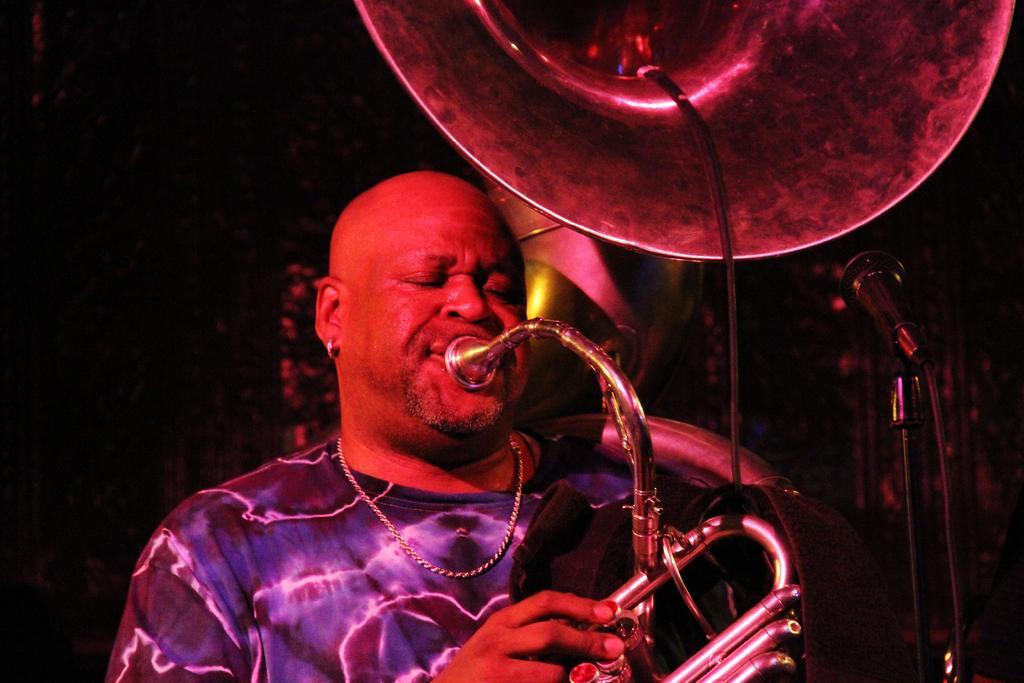Can you describe this image briefly? This image is clicked inside. There is a man wearing blue t-shirt is blowing trampoline. To the right, there is mic stand along with mic. 